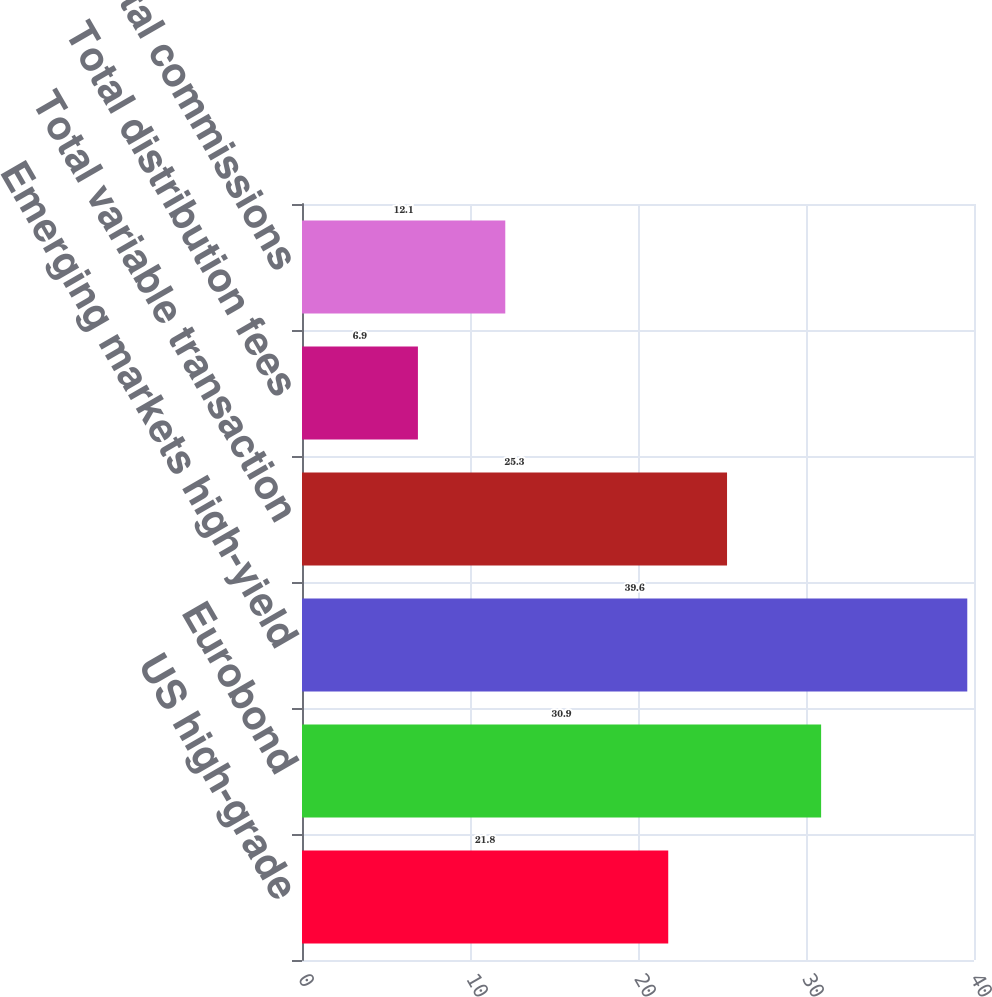<chart> <loc_0><loc_0><loc_500><loc_500><bar_chart><fcel>US high-grade<fcel>Eurobond<fcel>Emerging markets high-yield<fcel>Total variable transaction<fcel>Total distribution fees<fcel>Total commissions<nl><fcel>21.8<fcel>30.9<fcel>39.6<fcel>25.3<fcel>6.9<fcel>12.1<nl></chart> 